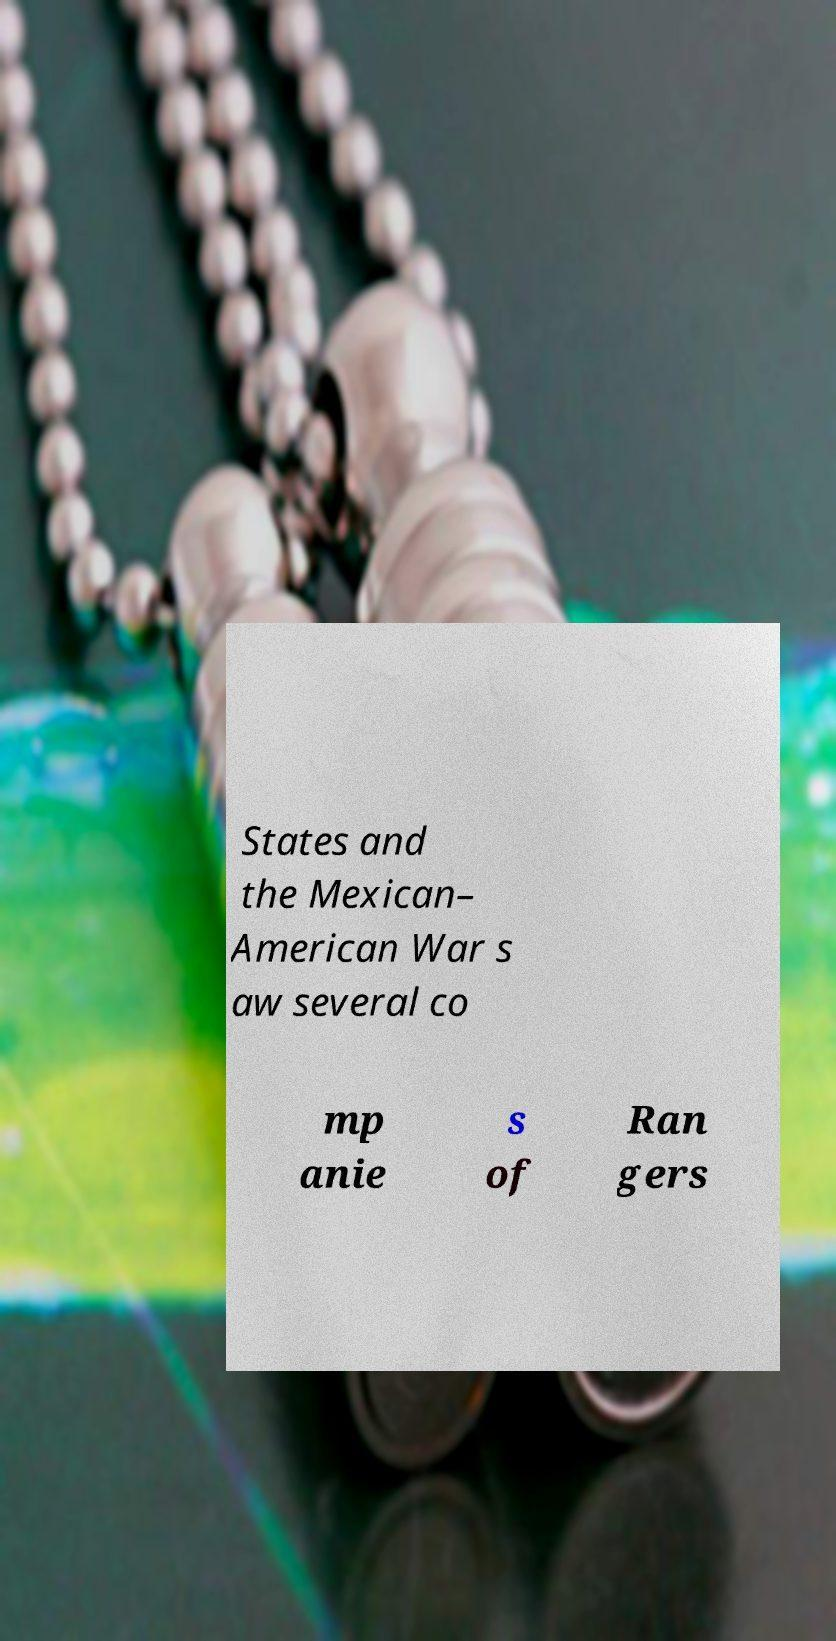Please read and relay the text visible in this image. What does it say? States and the Mexican– American War s aw several co mp anie s of Ran gers 